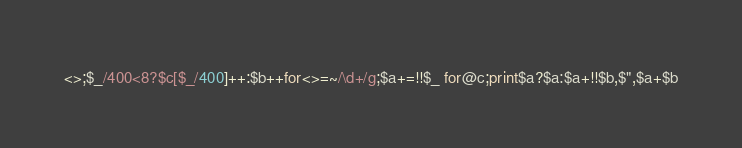Convert code to text. <code><loc_0><loc_0><loc_500><loc_500><_Perl_><>;$_/400<8?$c[$_/400]++:$b++for<>=~/\d+/g;$a+=!!$_ for@c;print$a?$a:$a+!!$b,$",$a+$b</code> 